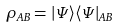<formula> <loc_0><loc_0><loc_500><loc_500>\rho _ { A B } = | \Psi \rangle \langle \Psi | _ { A B }</formula> 